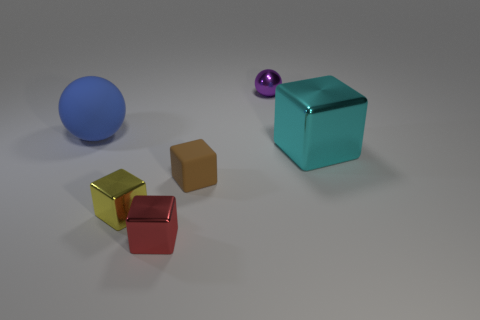Is the shape of the metallic thing behind the big cyan shiny thing the same as  the tiny red shiny object? no 